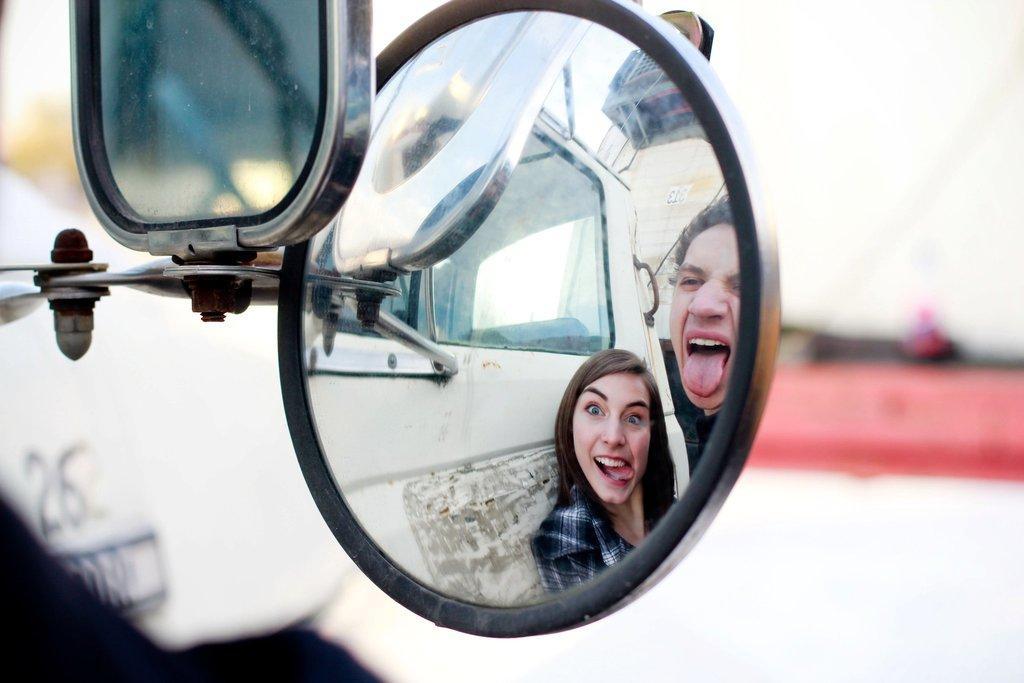Could you give a brief overview of what you see in this image? In this image, there are two mirrors. I can see the reflection of a vehicle and two people in one of the mirror. The background looks blurry. 